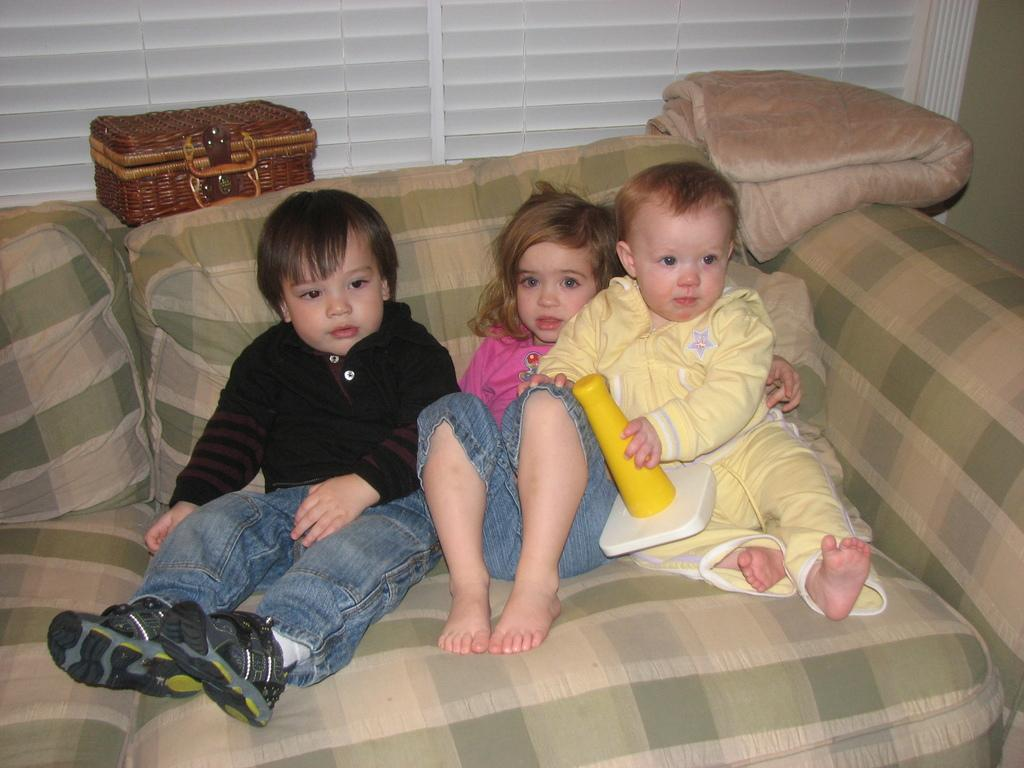How many children are in the image? There are three children in the image. What are the children doing in the image? The children are sitting on a couch. Can you describe the baby in the image? The baby is wearing a yellow dress and is one of the children. What is the baby holding in the image? The baby is holding a toy. What can be seen in the background of the image? There is a basket and a curtain in the background of the image. What type of chess piece is the baby holding in the image? The baby is not holding a chess piece in the image; they are holding a toy. Who is coaching the children in the image? There is no coach present in the image; the children are sitting on a couch by themselves. 